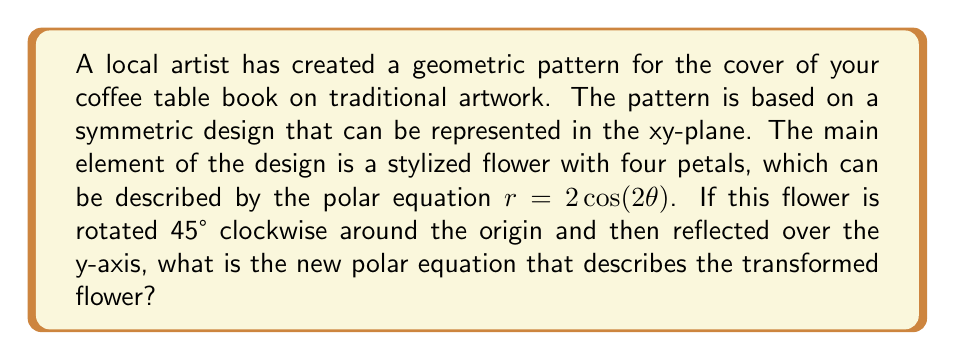Solve this math problem. Let's approach this step-by-step:

1) The original equation is $r = 2\cos(2\theta)$.

2) First, we need to rotate the flower 45° clockwise. In polar coordinates, a clockwise rotation by $\alpha$ is achieved by replacing $\theta$ with $(\theta + \alpha)$. Here, $\alpha = 45° = \frac{\pi}{4}$ radians.

   After rotation: $r = 2\cos(2(\theta + \frac{\pi}{4}))$

3) Now, we need to reflect this rotated flower over the y-axis. In polar coordinates, reflection over the y-axis is achieved by replacing $\theta$ with $(\pi - \theta)$.

   After reflection: $r = 2\cos(2(\pi - (\theta + \frac{\pi}{4})))$

4) Let's simplify the argument of cosine:
   
   $2(\pi - (\theta + \frac{\pi}{4})) = 2\pi - 2\theta - \frac{\pi}{2} = \frac{3\pi}{2} - 2\theta$

5) Therefore, the final equation is:

   $r = 2\cos(\frac{3\pi}{2} - 2\theta)$

6) We can simplify this further using the trigonometric identity $\cos(A - B) = \cos A \cos B + \sin A \sin B$:

   $r = 2\cos(\frac{3\pi}{2} - 2\theta) = 2(\cos \frac{3\pi}{2} \cos 2\theta + \sin \frac{3\pi}{2} \sin 2\theta)$

   $= 2(0 \cdot \cos 2\theta - 1 \cdot \sin 2\theta) = -2\sin(2\theta)$

Thus, the final simplified equation is $r = -2\sin(2\theta)$.
Answer: $r = -2\sin(2\theta)$ 